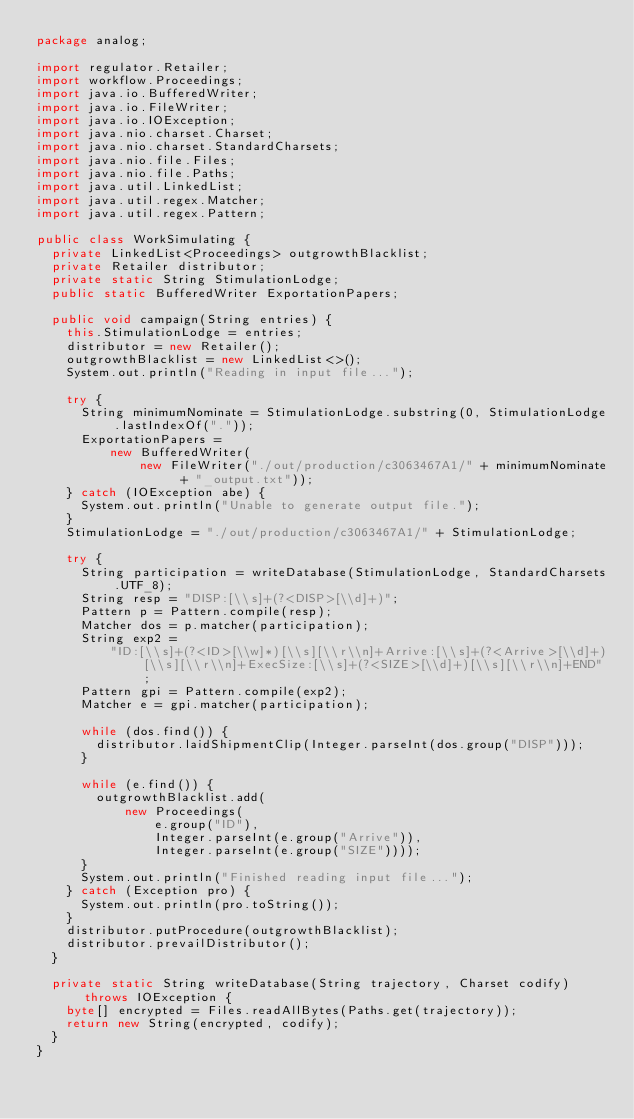Convert code to text. <code><loc_0><loc_0><loc_500><loc_500><_Java_>package analog;

import regulator.Retailer;
import workflow.Proceedings;
import java.io.BufferedWriter;
import java.io.FileWriter;
import java.io.IOException;
import java.nio.charset.Charset;
import java.nio.charset.StandardCharsets;
import java.nio.file.Files;
import java.nio.file.Paths;
import java.util.LinkedList;
import java.util.regex.Matcher;
import java.util.regex.Pattern;

public class WorkSimulating {
  private LinkedList<Proceedings> outgrowthBlacklist;
  private Retailer distributor;
  private static String StimulationLodge;
  public static BufferedWriter ExportationPapers;

  public void campaign(String entries) {
    this.StimulationLodge = entries;
    distributor = new Retailer();
    outgrowthBlacklist = new LinkedList<>();
    System.out.println("Reading in input file...");

    try {
      String minimumNominate = StimulationLodge.substring(0, StimulationLodge.lastIndexOf("."));
      ExportationPapers =
          new BufferedWriter(
              new FileWriter("./out/production/c3063467A1/" + minimumNominate + "_output.txt"));
    } catch (IOException abe) {
      System.out.println("Unable to generate output file.");
    }
    StimulationLodge = "./out/production/c3063467A1/" + StimulationLodge;

    try {
      String participation = writeDatabase(StimulationLodge, StandardCharsets.UTF_8);
      String resp = "DISP:[\\s]+(?<DISP>[\\d]+)";
      Pattern p = Pattern.compile(resp);
      Matcher dos = p.matcher(participation);
      String exp2 =
          "ID:[\\s]+(?<ID>[\\w]*)[\\s][\\r\\n]+Arrive:[\\s]+(?<Arrive>[\\d]+)[\\s][\\r\\n]+ExecSize:[\\s]+(?<SIZE>[\\d]+)[\\s][\\r\\n]+END";
      Pattern gpi = Pattern.compile(exp2);
      Matcher e = gpi.matcher(participation);

      while (dos.find()) {
        distributor.laidShipmentClip(Integer.parseInt(dos.group("DISP")));
      }

      while (e.find()) {
        outgrowthBlacklist.add(
            new Proceedings(
                e.group("ID"),
                Integer.parseInt(e.group("Arrive")),
                Integer.parseInt(e.group("SIZE"))));
      }
      System.out.println("Finished reading input file...");
    } catch (Exception pro) {
      System.out.println(pro.toString());
    }
    distributor.putProcedure(outgrowthBlacklist);
    distributor.prevailDistributor();
  }

  private static String writeDatabase(String trajectory, Charset codify) throws IOException {
    byte[] encrypted = Files.readAllBytes(Paths.get(trajectory));
    return new String(encrypted, codify);
  }
}
</code> 